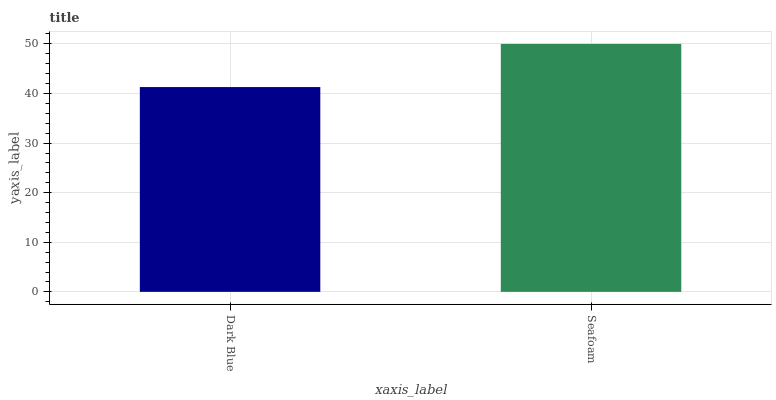Is Seafoam the minimum?
Answer yes or no. No. Is Seafoam greater than Dark Blue?
Answer yes or no. Yes. Is Dark Blue less than Seafoam?
Answer yes or no. Yes. Is Dark Blue greater than Seafoam?
Answer yes or no. No. Is Seafoam less than Dark Blue?
Answer yes or no. No. Is Seafoam the high median?
Answer yes or no. Yes. Is Dark Blue the low median?
Answer yes or no. Yes. Is Dark Blue the high median?
Answer yes or no. No. Is Seafoam the low median?
Answer yes or no. No. 